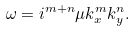Convert formula to latex. <formula><loc_0><loc_0><loc_500><loc_500>\omega = i ^ { m + n } \mu k _ { x } ^ { m } k _ { y } ^ { n } .</formula> 